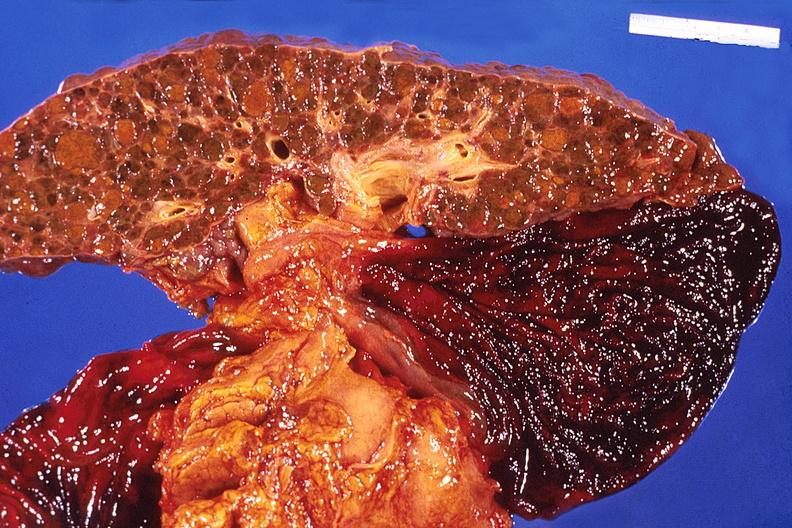what does this image show?
Answer the question using a single word or phrase. Liver 